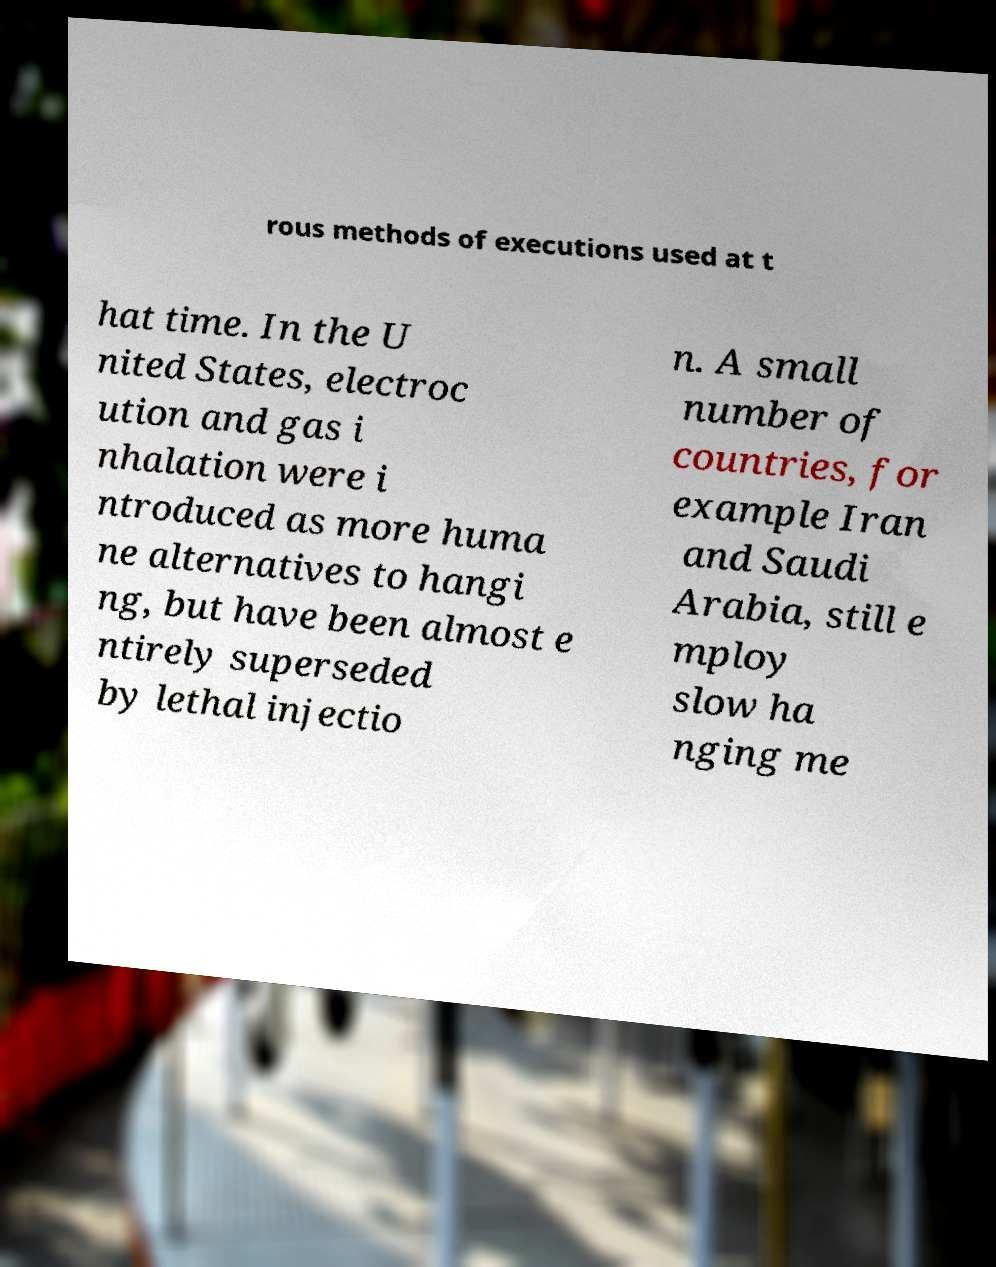Can you read and provide the text displayed in the image?This photo seems to have some interesting text. Can you extract and type it out for me? rous methods of executions used at t hat time. In the U nited States, electroc ution and gas i nhalation were i ntroduced as more huma ne alternatives to hangi ng, but have been almost e ntirely superseded by lethal injectio n. A small number of countries, for example Iran and Saudi Arabia, still e mploy slow ha nging me 